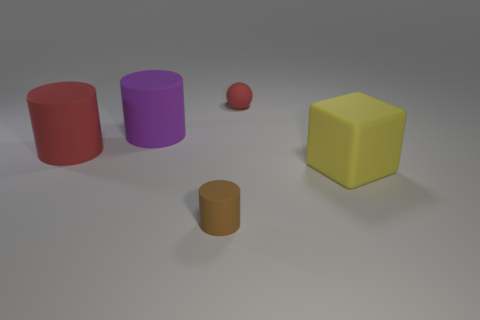Add 4 tiny brown matte cylinders. How many objects exist? 9 Subtract all spheres. How many objects are left? 4 Subtract all red shiny cylinders. Subtract all big purple matte cylinders. How many objects are left? 4 Add 2 red matte things. How many red matte things are left? 4 Add 2 small rubber cylinders. How many small rubber cylinders exist? 3 Subtract 0 green cubes. How many objects are left? 5 